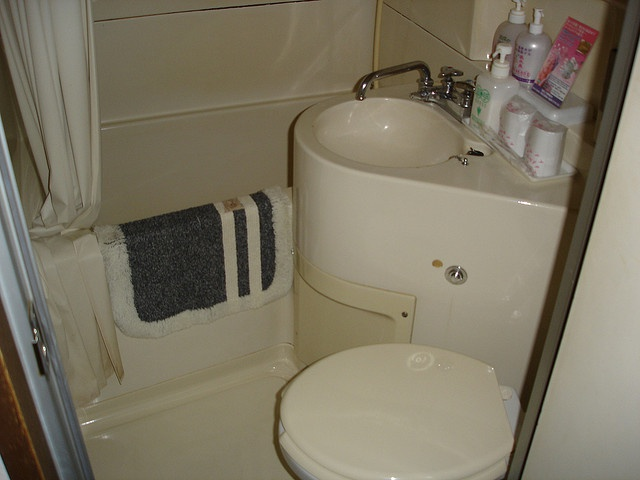Describe the objects in this image and their specific colors. I can see toilet in gray, darkgray, and black tones, sink in gray and darkgray tones, bottle in gray and darkgray tones, bottle in gray and purple tones, and bottle in gray tones in this image. 